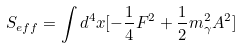Convert formula to latex. <formula><loc_0><loc_0><loc_500><loc_500>S _ { e f f } = \int d ^ { 4 } x [ - \frac { 1 } { 4 } F ^ { 2 } + \frac { 1 } { 2 } m _ { \gamma } ^ { 2 } A ^ { 2 } ]</formula> 